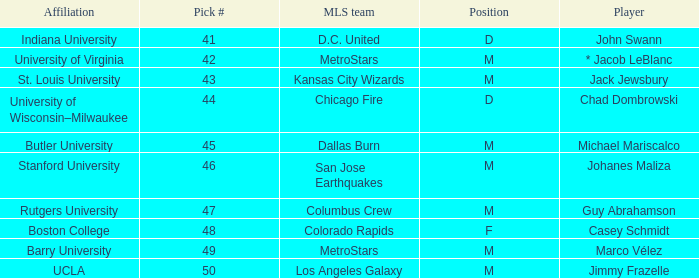Would you be able to parse every entry in this table? {'header': ['Affiliation', 'Pick #', 'MLS team', 'Position', 'Player'], 'rows': [['Indiana University', '41', 'D.C. United', 'D', 'John Swann'], ['University of Virginia', '42', 'MetroStars', 'M', '* Jacob LeBlanc'], ['St. Louis University', '43', 'Kansas City Wizards', 'M', 'Jack Jewsbury'], ['University of Wisconsin–Milwaukee', '44', 'Chicago Fire', 'D', 'Chad Dombrowski'], ['Butler University', '45', 'Dallas Burn', 'M', 'Michael Mariscalco'], ['Stanford University', '46', 'San Jose Earthquakes', 'M', 'Johanes Maliza'], ['Rutgers University', '47', 'Columbus Crew', 'M', 'Guy Abrahamson'], ['Boston College', '48', 'Colorado Rapids', 'F', 'Casey Schmidt'], ['Barry University', '49', 'MetroStars', 'M', 'Marco Vélez'], ['UCLA', '50', 'Los Angeles Galaxy', 'M', 'Jimmy Frazelle']]} What position has UCLA pick that is larger than #47? M. 